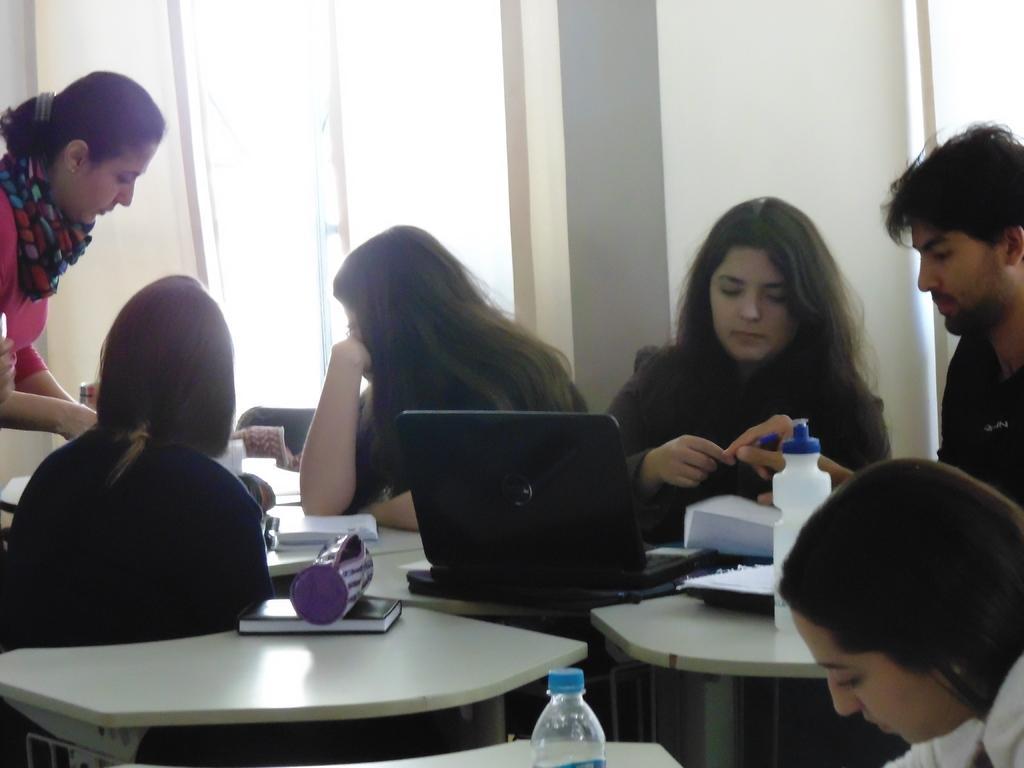Please provide a concise description of this image. There is a woman sitting at the right corner. He is a man at the right corner. There is other woman who is at the right corner. This is a laptop which is placed on a table. There is also a book which is placed on the table and there are three woman. One is at the left corner. One is sitting at the center and one is left corner. 